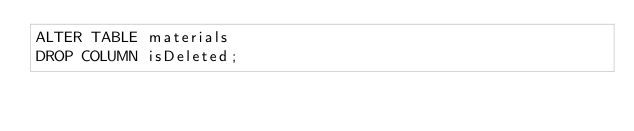Convert code to text. <code><loc_0><loc_0><loc_500><loc_500><_SQL_>ALTER TABLE materials
DROP COLUMN isDeleted;</code> 